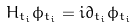<formula> <loc_0><loc_0><loc_500><loc_500>H _ { t _ { i } } \phi _ { t _ { i } } = i \partial _ { t _ { i } } \phi _ { t _ { i } }</formula> 